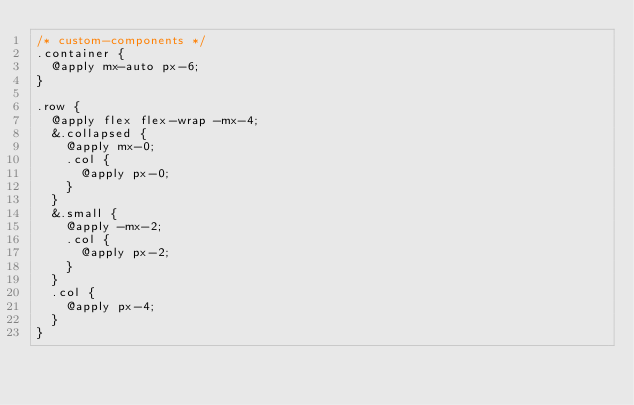Convert code to text. <code><loc_0><loc_0><loc_500><loc_500><_CSS_>/* custom-components */
.container {
  @apply mx-auto px-6;
}

.row {
  @apply flex flex-wrap -mx-4;
  &.collapsed {
    @apply mx-0;
    .col {
      @apply px-0;
    }
  }
  &.small {
    @apply -mx-2;
    .col {
      @apply px-2;
    }
  }
  .col {
    @apply px-4;
  }
}
</code> 